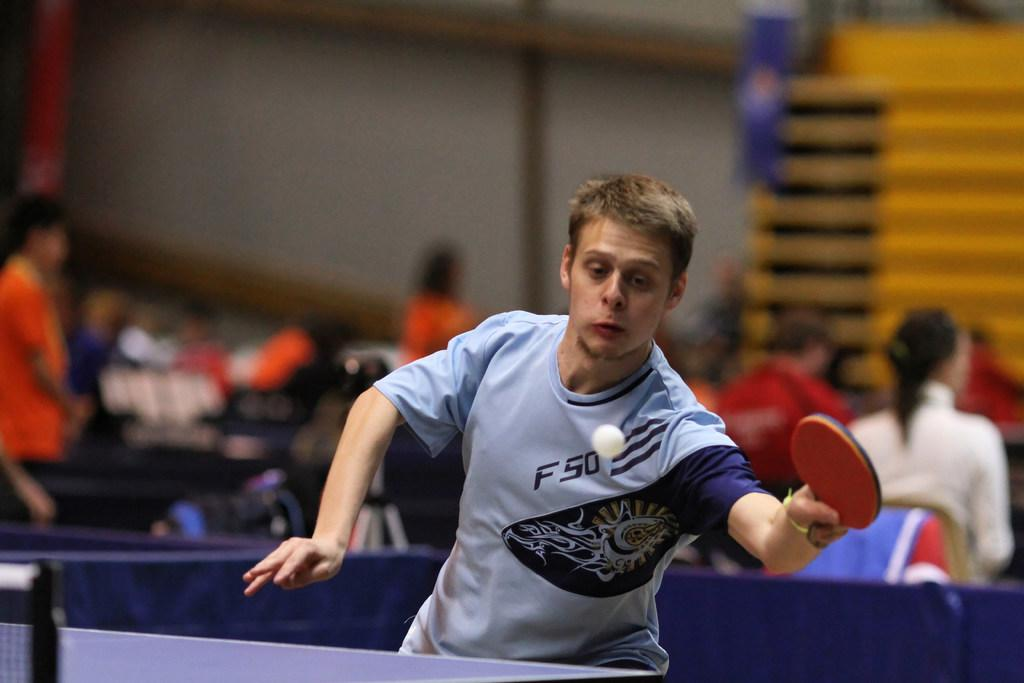<image>
Offer a succinct explanation of the picture presented. A guy playing pink pong has a shirt with F50 on the front of it. 